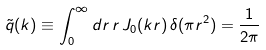<formula> <loc_0><loc_0><loc_500><loc_500>\tilde { q } ( k ) \equiv \int _ { 0 } ^ { \infty } d r \, r \, J _ { 0 } ( k r ) \, \delta ( \pi r ^ { 2 } ) = \frac { 1 } { 2 \pi }</formula> 